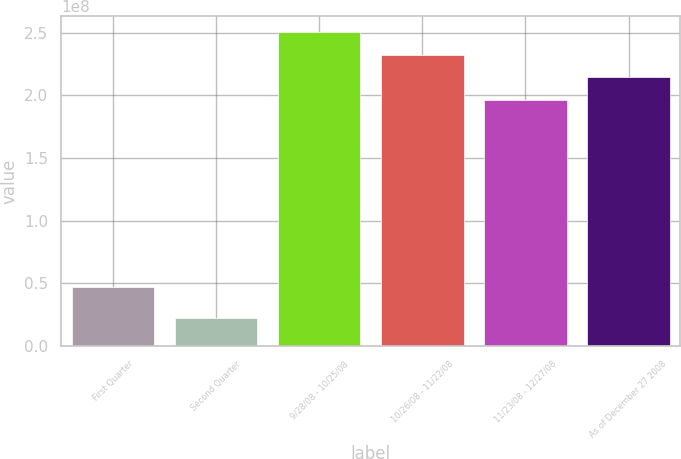<chart> <loc_0><loc_0><loc_500><loc_500><bar_chart><fcel>First Quarter<fcel>Second Quarter<fcel>9/28/08 - 10/25/08<fcel>10/26/08 - 11/22/08<fcel>11/23/08 - 12/27/08<fcel>As of December 27 2008<nl><fcel>4.71993e+07<fcel>2.22634e+07<fcel>2.50515e+08<fcel>2.32419e+08<fcel>1.96229e+08<fcel>2.14324e+08<nl></chart> 